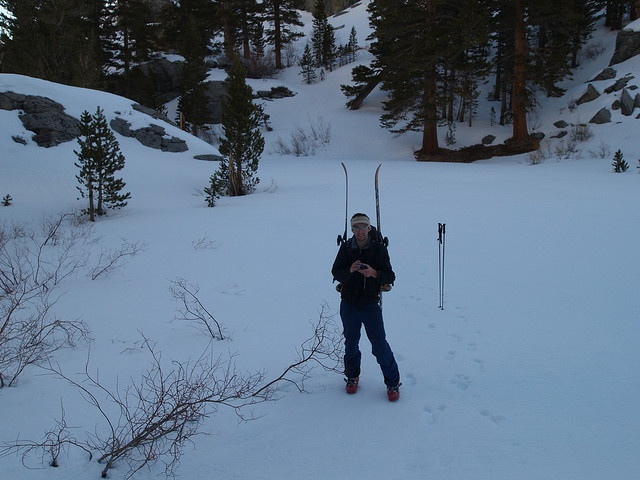Describe the objects in this image and their specific colors. I can see people in purple, black, gray, and darkgray tones, skis in purple, gray, and black tones, and backpack in purple, black, gray, and navy tones in this image. 